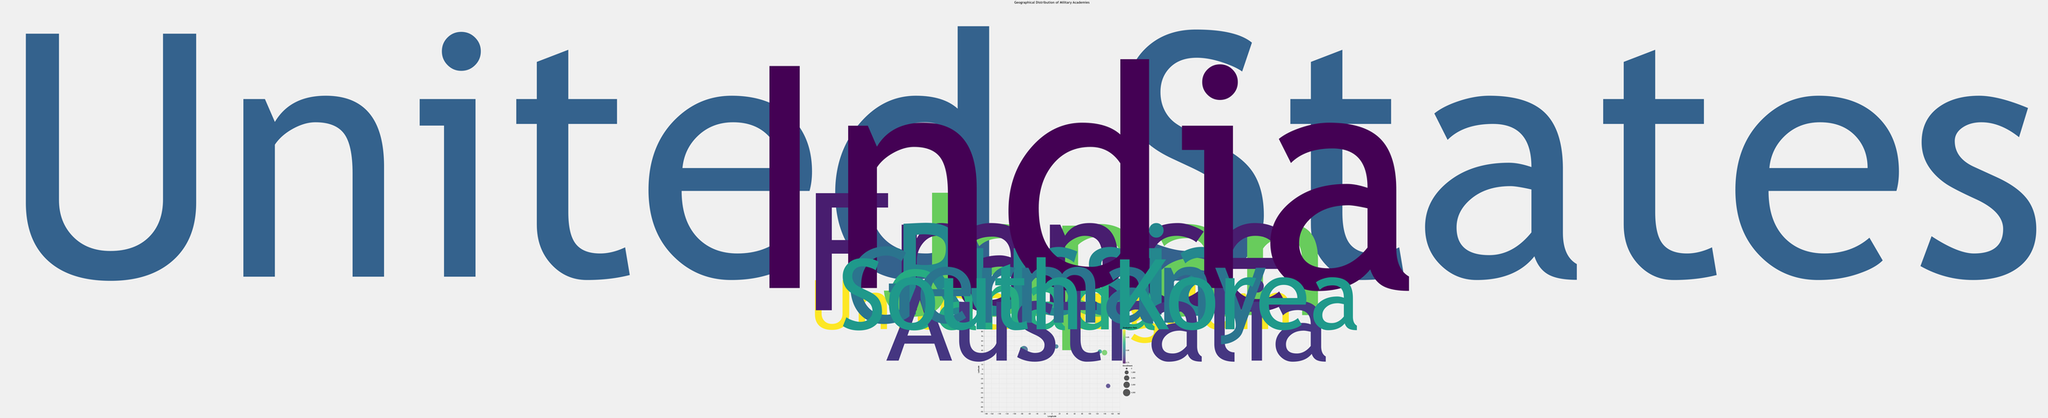What is the title of the bubble chart? The title of the chart is provided at the top center and is written in a slightly larger font size. It reads "Geographical Distribution of Military Academies."
Answer: Geographical Distribution of Military Academies What does the size of each bubble represent? The size of each bubble represents the enrollment numbers at each military academy. Larger bubbles indicate higher enrollments and smaller bubbles indicate lower enrollments.
Answer: Enrollment Which military academy has the highest enrollment and where is it located? By observing the largest bubble on the chart, we see that the United States Military Academy has the highest enrollment with 4400 students. It is located in the United States (Latitude: 41.3887, Longitude: -73.9643).
Answer: United States Military Academy, United States Which military academy has the highest graduation rate and what is its rate? The graduation rate is depicted by color intensity, where lighter colors indicate higher rates. The Royal Military Academy Sandhurst, located in the United Kingdom, has the highest graduation rate of 0.88.
Answer: Royal Military Academy Sandhurst, 0.88 Compare the military academies in terms of enrollment between the Indian Military Academy and the National Defense Academy of Japan. Which one has more students and by how many? The Indian Military Academy has an enrollment of 4000 students, while the National Defense Academy of Japan has an enrollment of 2100 students. The difference in enrollment is 4000 - 2100 = 1900 students.
Answer: Indian Military Academy, 1900 What is the average graduation rate of all military academies on the chart? To find the average graduation rate, sum all the graduation rates and then divide by the number of academies: (0.79 + 0.88 + 0.85 + 0.76 + 0.81 + 0.83 + 0.77 + 0.75 + 0.80 + 0.82) / 10 = 8.06 / 10 = 0.806
Answer: 0.81 Which country has the military academy with the second highest graduation rate and what is the rate? The second highest graduation rate on the chart, after the Royal Military Academy Sandhurst (0.88), is 0.85 which belongs to the National Defense Academy of Japan.
Answer: Japan, 0.85 What geographical region has the highest concentration of military academies according to the chart? By visually inspecting the chart, the European region has the highest concentration of military academies, including the United Kingdom, France, and Germany.
Answer: Europe Considering only the academies located in Asia, which one has the lowest enrollment? The military academies in Asia are National Defense Academy of Japan, Indian Military Academy, and Korea Military Academy. Among these, the Korea Military Academy has the lowest enrollment with 1100 students.
Answer: Korea Military Academy, 1100 Identify the academy with the smallest enrollment and provide details on its location and graduation rate. The smallest bubble on the chart indicates that the Royal Military Academy Sandhurst in the United Kingdom has the smallest enrollment with 700 students. Its graduation rate is 0.88.
Answer: Royal Military Academy Sandhurst, United Kingdom, 0.88 